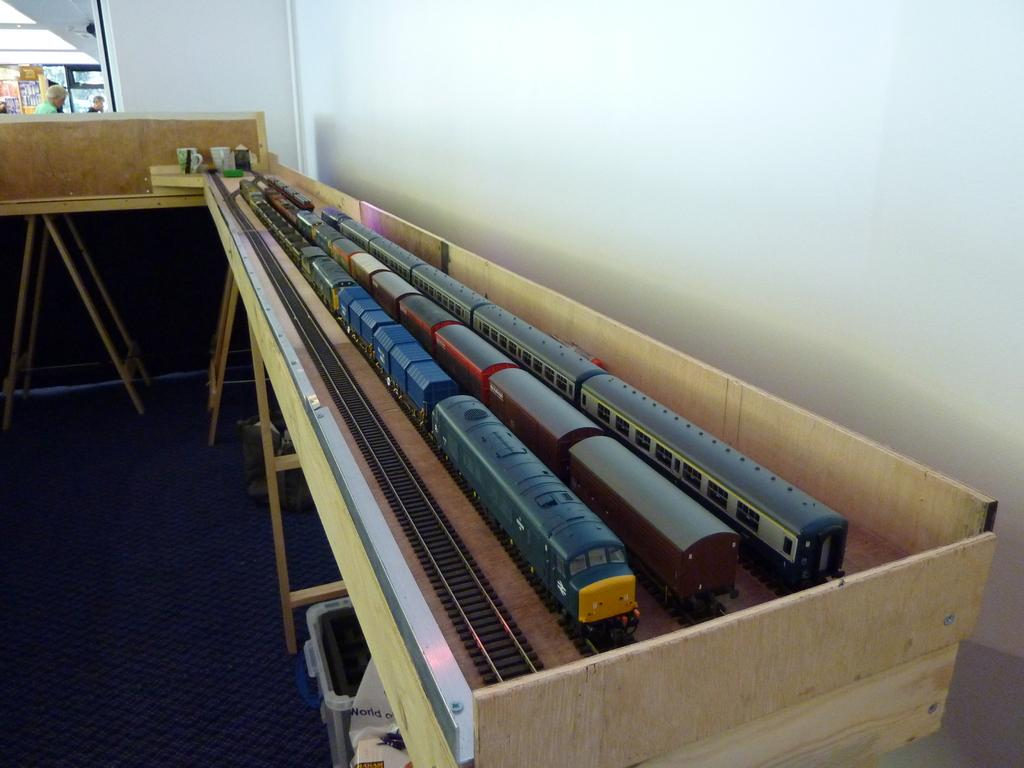What type of toys are on the track in the image? There are train toys on the track in the image. What kind of track is shown in the image? The track is a train track. What piece of furniture is visible in the image? The image shows a table. What is the background of the image made of? There is a wall in the image. What part of the room can be seen in the image? The floor is visible in the image. What are the people in the image wearing? There are people wearing clothes in the image. What type of leather is being used to make the train whistle in the image? There is no train whistle present in the image, and therefore no leather can be associated with it. 